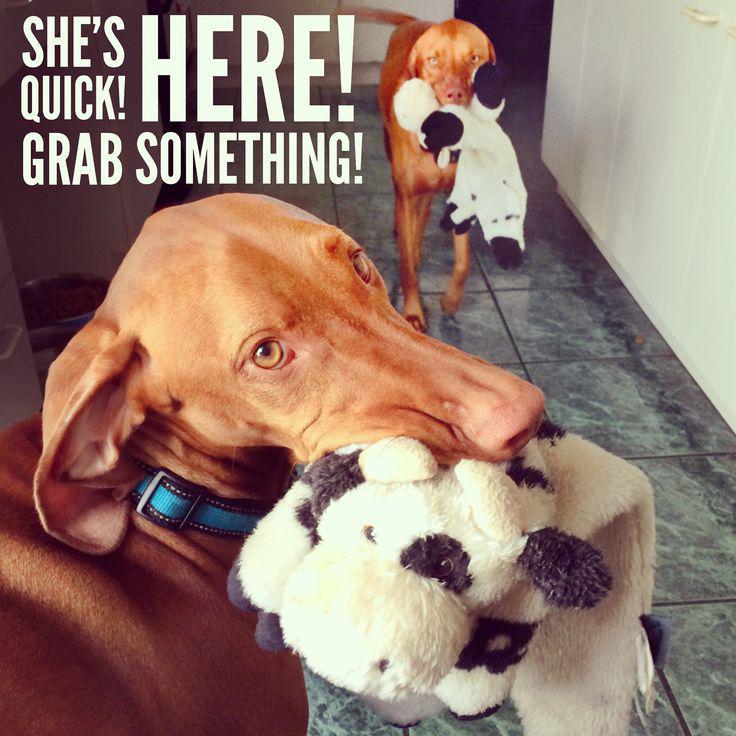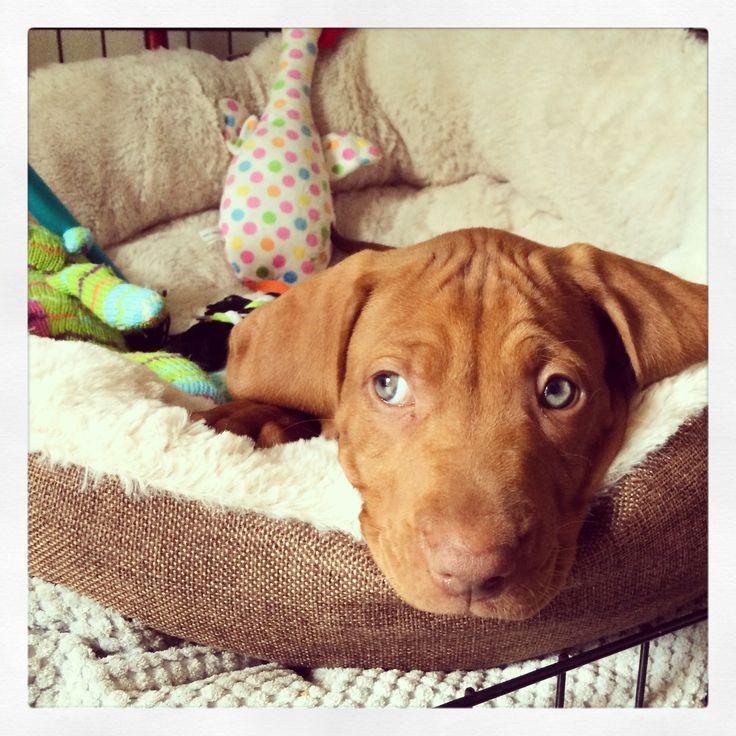The first image is the image on the left, the second image is the image on the right. Given the left and right images, does the statement "There are 3 or more dogs in one of the images." hold true? Answer yes or no. No. The first image is the image on the left, the second image is the image on the right. Analyze the images presented: Is the assertion "The right image shows multiple dogs in a container, with at least one paw over the edge on each side." valid? Answer yes or no. No. 